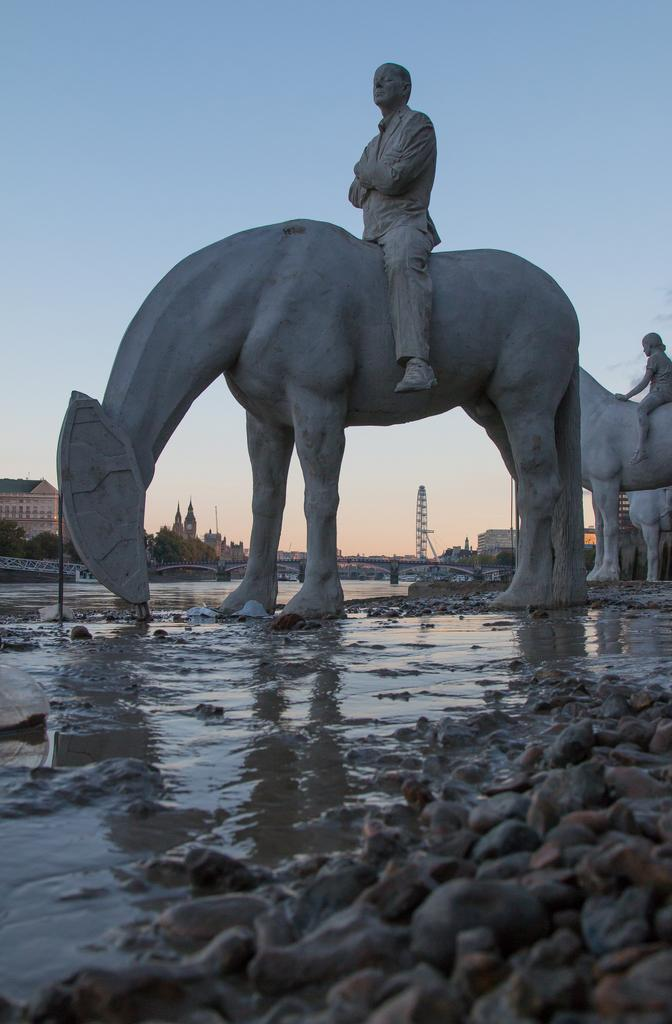What is the main subject of the image? There is a statue in the image. What is the statue depicting? The statue depicts a person sitting on an animal. What can be seen at the bottom of the image? There are stones and water in the bottom of the image. What type of ball is being used by the person sitting on the zebra in the image? There is no ball or zebra present in the image; the statue depicts a person sitting on an animal, but the specific animal is not identified as a zebra. 